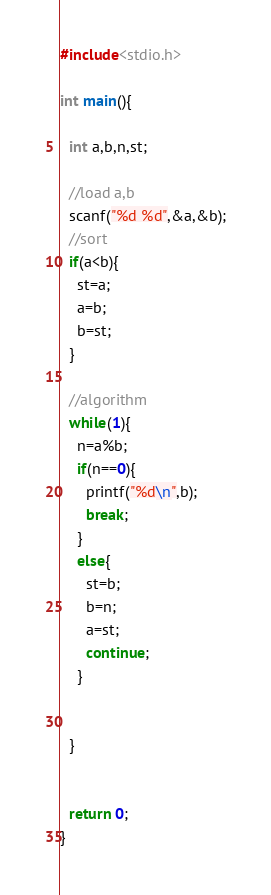Convert code to text. <code><loc_0><loc_0><loc_500><loc_500><_C_>#include<stdio.h>

int main(){

  int a,b,n,st;

  //load a,b 
  scanf("%d %d",&a,&b);
  //sort
  if(a<b){
    st=a;
    a=b;
    b=st;
  }

  //algorithm
  while(1){
    n=a%b;
    if(n==0){
      printf("%d\n",b);
      break;
    }
    else{
      st=b;
      b=n;
      a=st;
      continue;
    }


  }


  return 0;
}</code> 